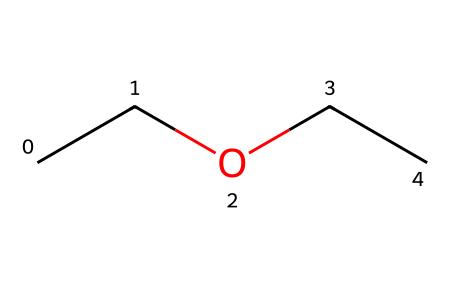What is the molecular formula of diethyl ether? The SMILES representation CCOCC indicates that there are two ethyl (C2H5) groups connected by an oxygen atom (O). Combining these gives the molecular formula C4H10O.
Answer: C4H10O How many carbon atoms are in diethyl ether? By analyzing the SMILES CCOCC, there are four carbon (C) atoms represented. Each "C" corresponds to a carbon atom in the structure.
Answer: 4 What type of functional group is present in diethyl ether? The presence of an ether linkage (R-O-R) is evident in the SMILES representation, where "CCOCC" features an oxygen atom (O) between two carbon chains (ethyl groups).
Answer: ether How many hydrogen atoms are attached to the carbon backbone in diethyl ether? In CCOCC, each carbon typically bonds with enough hydrogens to have four bonds total. The two terminal carbons (C) in the ethyl groups each bond with three hydrogens, while the two central carbons bond with two. Thus, total hydrogens equal 10.
Answer: 10 What is one major property of diethyl ether as an anesthetic? Diethyl ether is known for its volatility, meaning it can easily vaporize at room temperature, making it effective for inhalational anesthesia.
Answer: volatility What is the role of oxygen in diethyl ether's structure? The oxygen atom (O) serves as the central atom that links the two ethyl groups (C2H5). This ether functional group is crucial for its properties such as the ability to act as a solvent and anesthetic.
Answer: linking ethyl groups 